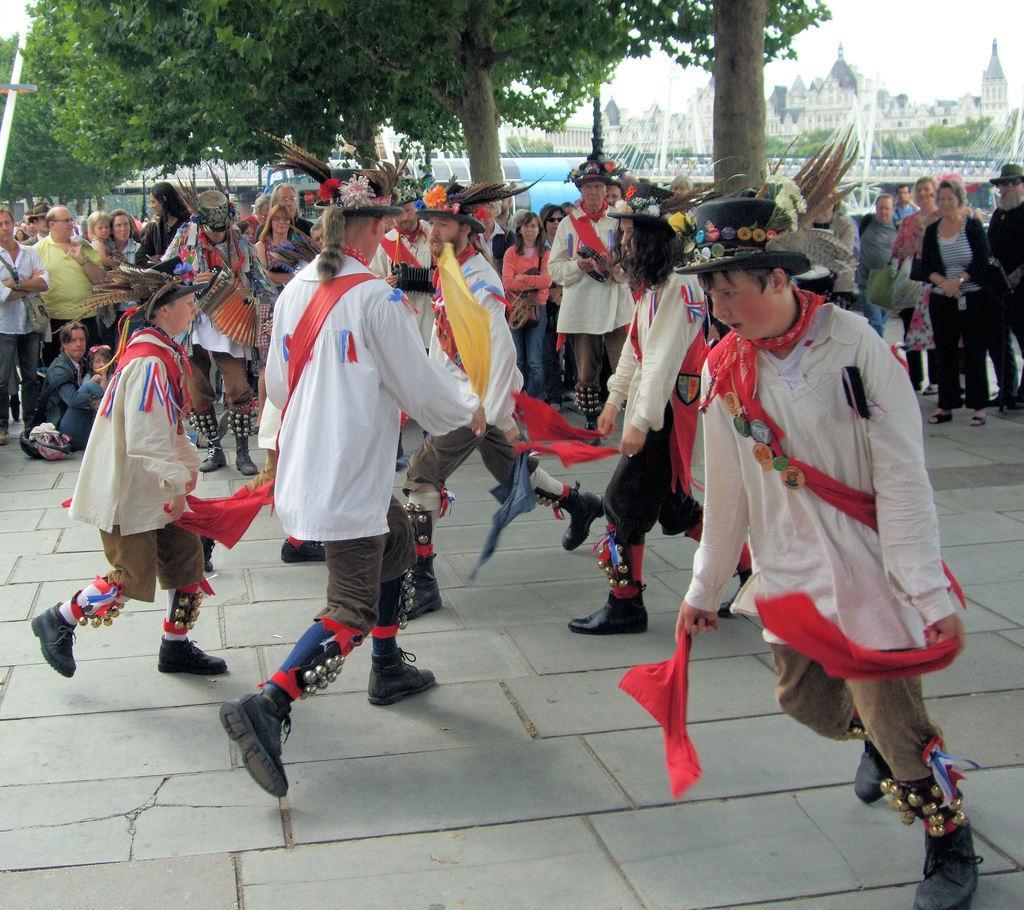Please provide a concise description of this image. In this picture we can see some people are performing in the front, they are holding clothes, in the background there are some people standing, we can also see some trees and buildings in the background, there is the sky at the right top of the picture, the people in the front wire caps. 